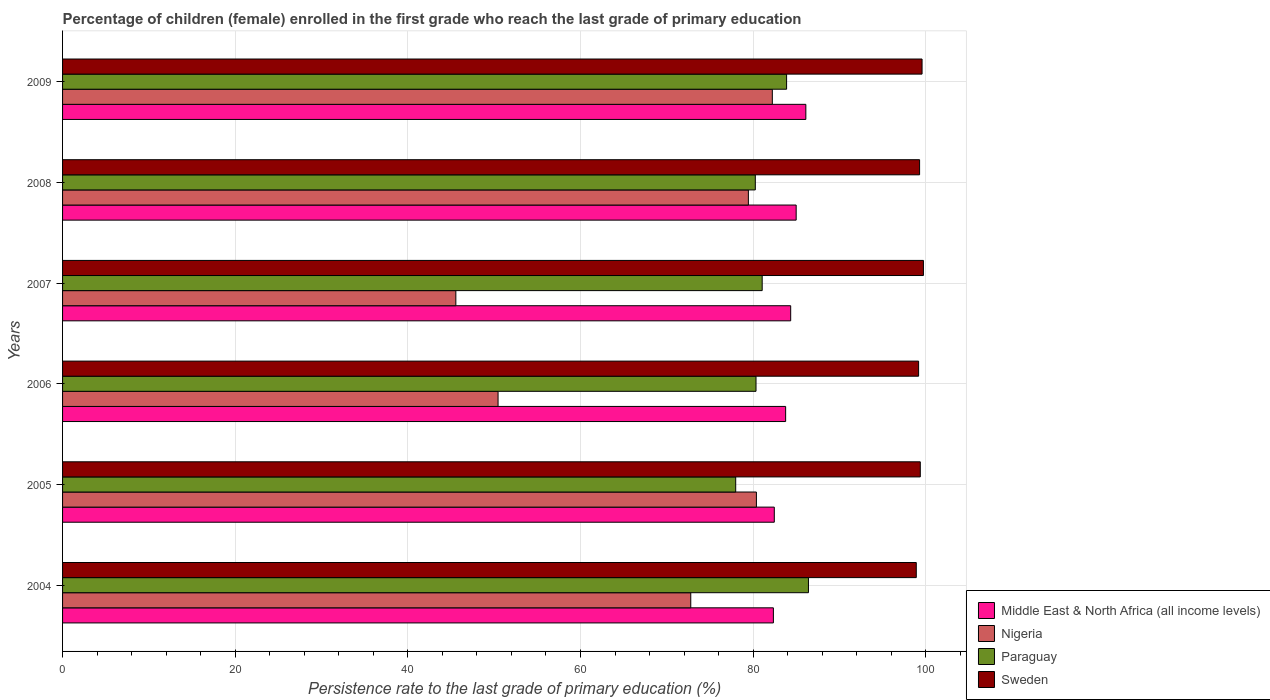How many different coloured bars are there?
Make the answer very short. 4. How many groups of bars are there?
Keep it short and to the point. 6. Are the number of bars per tick equal to the number of legend labels?
Give a very brief answer. Yes. How many bars are there on the 6th tick from the top?
Ensure brevity in your answer.  4. What is the label of the 2nd group of bars from the top?
Your answer should be compact. 2008. In how many cases, is the number of bars for a given year not equal to the number of legend labels?
Offer a terse response. 0. What is the persistence rate of children in Middle East & North Africa (all income levels) in 2004?
Keep it short and to the point. 82.34. Across all years, what is the maximum persistence rate of children in Nigeria?
Provide a short and direct response. 82.22. Across all years, what is the minimum persistence rate of children in Middle East & North Africa (all income levels)?
Keep it short and to the point. 82.34. In which year was the persistence rate of children in Paraguay maximum?
Make the answer very short. 2004. In which year was the persistence rate of children in Sweden minimum?
Offer a terse response. 2004. What is the total persistence rate of children in Nigeria in the graph?
Make the answer very short. 410.82. What is the difference between the persistence rate of children in Paraguay in 2005 and that in 2009?
Give a very brief answer. -5.9. What is the difference between the persistence rate of children in Sweden in 2004 and the persistence rate of children in Nigeria in 2005?
Offer a very short reply. 18.52. What is the average persistence rate of children in Nigeria per year?
Give a very brief answer. 68.47. In the year 2009, what is the difference between the persistence rate of children in Sweden and persistence rate of children in Middle East & North Africa (all income levels)?
Ensure brevity in your answer.  13.46. In how many years, is the persistence rate of children in Middle East & North Africa (all income levels) greater than 52 %?
Offer a very short reply. 6. What is the ratio of the persistence rate of children in Nigeria in 2007 to that in 2008?
Give a very brief answer. 0.57. Is the difference between the persistence rate of children in Sweden in 2005 and 2008 greater than the difference between the persistence rate of children in Middle East & North Africa (all income levels) in 2005 and 2008?
Keep it short and to the point. Yes. What is the difference between the highest and the second highest persistence rate of children in Nigeria?
Your answer should be compact. 1.84. What is the difference between the highest and the lowest persistence rate of children in Paraguay?
Keep it short and to the point. 8.43. Is the sum of the persistence rate of children in Nigeria in 2004 and 2005 greater than the maximum persistence rate of children in Paraguay across all years?
Offer a very short reply. Yes. Is it the case that in every year, the sum of the persistence rate of children in Sweden and persistence rate of children in Paraguay is greater than the sum of persistence rate of children in Middle East & North Africa (all income levels) and persistence rate of children in Nigeria?
Offer a terse response. Yes. What does the 1st bar from the top in 2008 represents?
Your answer should be very brief. Sweden. Is it the case that in every year, the sum of the persistence rate of children in Middle East & North Africa (all income levels) and persistence rate of children in Paraguay is greater than the persistence rate of children in Nigeria?
Provide a succinct answer. Yes. How many bars are there?
Provide a short and direct response. 24. Does the graph contain any zero values?
Your answer should be compact. No. Does the graph contain grids?
Offer a very short reply. Yes. How many legend labels are there?
Your answer should be compact. 4. What is the title of the graph?
Make the answer very short. Percentage of children (female) enrolled in the first grade who reach the last grade of primary education. What is the label or title of the X-axis?
Provide a succinct answer. Persistence rate to the last grade of primary education (%). What is the label or title of the Y-axis?
Offer a terse response. Years. What is the Persistence rate to the last grade of primary education (%) in Middle East & North Africa (all income levels) in 2004?
Give a very brief answer. 82.34. What is the Persistence rate to the last grade of primary education (%) in Nigeria in 2004?
Keep it short and to the point. 72.77. What is the Persistence rate to the last grade of primary education (%) in Paraguay in 2004?
Offer a very short reply. 86.41. What is the Persistence rate to the last grade of primary education (%) of Sweden in 2004?
Make the answer very short. 98.9. What is the Persistence rate to the last grade of primary education (%) of Middle East & North Africa (all income levels) in 2005?
Your response must be concise. 82.45. What is the Persistence rate to the last grade of primary education (%) of Nigeria in 2005?
Ensure brevity in your answer.  80.38. What is the Persistence rate to the last grade of primary education (%) of Paraguay in 2005?
Offer a very short reply. 77.98. What is the Persistence rate to the last grade of primary education (%) of Sweden in 2005?
Give a very brief answer. 99.36. What is the Persistence rate to the last grade of primary education (%) of Middle East & North Africa (all income levels) in 2006?
Make the answer very short. 83.76. What is the Persistence rate to the last grade of primary education (%) of Nigeria in 2006?
Offer a very short reply. 50.45. What is the Persistence rate to the last grade of primary education (%) of Paraguay in 2006?
Provide a short and direct response. 80.33. What is the Persistence rate to the last grade of primary education (%) of Sweden in 2006?
Give a very brief answer. 99.17. What is the Persistence rate to the last grade of primary education (%) in Middle East & North Africa (all income levels) in 2007?
Your answer should be compact. 84.35. What is the Persistence rate to the last grade of primary education (%) of Nigeria in 2007?
Give a very brief answer. 45.56. What is the Persistence rate to the last grade of primary education (%) of Paraguay in 2007?
Ensure brevity in your answer.  81.05. What is the Persistence rate to the last grade of primary education (%) of Sweden in 2007?
Provide a succinct answer. 99.72. What is the Persistence rate to the last grade of primary education (%) of Middle East & North Africa (all income levels) in 2008?
Offer a very short reply. 84.98. What is the Persistence rate to the last grade of primary education (%) in Nigeria in 2008?
Give a very brief answer. 79.44. What is the Persistence rate to the last grade of primary education (%) of Paraguay in 2008?
Keep it short and to the point. 80.25. What is the Persistence rate to the last grade of primary education (%) of Sweden in 2008?
Give a very brief answer. 99.28. What is the Persistence rate to the last grade of primary education (%) in Middle East & North Africa (all income levels) in 2009?
Give a very brief answer. 86.1. What is the Persistence rate to the last grade of primary education (%) of Nigeria in 2009?
Your response must be concise. 82.22. What is the Persistence rate to the last grade of primary education (%) of Paraguay in 2009?
Your answer should be compact. 83.87. What is the Persistence rate to the last grade of primary education (%) of Sweden in 2009?
Provide a short and direct response. 99.57. Across all years, what is the maximum Persistence rate to the last grade of primary education (%) in Middle East & North Africa (all income levels)?
Give a very brief answer. 86.1. Across all years, what is the maximum Persistence rate to the last grade of primary education (%) of Nigeria?
Provide a short and direct response. 82.22. Across all years, what is the maximum Persistence rate to the last grade of primary education (%) in Paraguay?
Provide a succinct answer. 86.41. Across all years, what is the maximum Persistence rate to the last grade of primary education (%) in Sweden?
Your response must be concise. 99.72. Across all years, what is the minimum Persistence rate to the last grade of primary education (%) of Middle East & North Africa (all income levels)?
Your answer should be very brief. 82.34. Across all years, what is the minimum Persistence rate to the last grade of primary education (%) of Nigeria?
Provide a succinct answer. 45.56. Across all years, what is the minimum Persistence rate to the last grade of primary education (%) in Paraguay?
Your response must be concise. 77.98. Across all years, what is the minimum Persistence rate to the last grade of primary education (%) in Sweden?
Give a very brief answer. 98.9. What is the total Persistence rate to the last grade of primary education (%) of Middle East & North Africa (all income levels) in the graph?
Give a very brief answer. 503.99. What is the total Persistence rate to the last grade of primary education (%) in Nigeria in the graph?
Keep it short and to the point. 410.82. What is the total Persistence rate to the last grade of primary education (%) of Paraguay in the graph?
Make the answer very short. 489.88. What is the total Persistence rate to the last grade of primary education (%) of Sweden in the graph?
Offer a terse response. 595.99. What is the difference between the Persistence rate to the last grade of primary education (%) of Middle East & North Africa (all income levels) in 2004 and that in 2005?
Provide a short and direct response. -0.1. What is the difference between the Persistence rate to the last grade of primary education (%) of Nigeria in 2004 and that in 2005?
Your answer should be very brief. -7.61. What is the difference between the Persistence rate to the last grade of primary education (%) in Paraguay in 2004 and that in 2005?
Offer a terse response. 8.43. What is the difference between the Persistence rate to the last grade of primary education (%) in Sweden in 2004 and that in 2005?
Provide a succinct answer. -0.46. What is the difference between the Persistence rate to the last grade of primary education (%) in Middle East & North Africa (all income levels) in 2004 and that in 2006?
Your answer should be compact. -1.42. What is the difference between the Persistence rate to the last grade of primary education (%) of Nigeria in 2004 and that in 2006?
Keep it short and to the point. 22.32. What is the difference between the Persistence rate to the last grade of primary education (%) in Paraguay in 2004 and that in 2006?
Ensure brevity in your answer.  6.07. What is the difference between the Persistence rate to the last grade of primary education (%) of Sweden in 2004 and that in 2006?
Your answer should be compact. -0.27. What is the difference between the Persistence rate to the last grade of primary education (%) of Middle East & North Africa (all income levels) in 2004 and that in 2007?
Offer a very short reply. -2. What is the difference between the Persistence rate to the last grade of primary education (%) of Nigeria in 2004 and that in 2007?
Offer a terse response. 27.21. What is the difference between the Persistence rate to the last grade of primary education (%) in Paraguay in 2004 and that in 2007?
Your answer should be compact. 5.36. What is the difference between the Persistence rate to the last grade of primary education (%) of Sweden in 2004 and that in 2007?
Offer a terse response. -0.83. What is the difference between the Persistence rate to the last grade of primary education (%) of Middle East & North Africa (all income levels) in 2004 and that in 2008?
Ensure brevity in your answer.  -2.64. What is the difference between the Persistence rate to the last grade of primary education (%) in Nigeria in 2004 and that in 2008?
Provide a short and direct response. -6.67. What is the difference between the Persistence rate to the last grade of primary education (%) in Paraguay in 2004 and that in 2008?
Provide a succinct answer. 6.15. What is the difference between the Persistence rate to the last grade of primary education (%) of Sweden in 2004 and that in 2008?
Your response must be concise. -0.38. What is the difference between the Persistence rate to the last grade of primary education (%) in Middle East & North Africa (all income levels) in 2004 and that in 2009?
Offer a terse response. -3.76. What is the difference between the Persistence rate to the last grade of primary education (%) of Nigeria in 2004 and that in 2009?
Provide a succinct answer. -9.45. What is the difference between the Persistence rate to the last grade of primary education (%) of Paraguay in 2004 and that in 2009?
Keep it short and to the point. 2.53. What is the difference between the Persistence rate to the last grade of primary education (%) of Sweden in 2004 and that in 2009?
Give a very brief answer. -0.67. What is the difference between the Persistence rate to the last grade of primary education (%) of Middle East & North Africa (all income levels) in 2005 and that in 2006?
Provide a succinct answer. -1.31. What is the difference between the Persistence rate to the last grade of primary education (%) of Nigeria in 2005 and that in 2006?
Ensure brevity in your answer.  29.93. What is the difference between the Persistence rate to the last grade of primary education (%) in Paraguay in 2005 and that in 2006?
Your answer should be very brief. -2.35. What is the difference between the Persistence rate to the last grade of primary education (%) in Sweden in 2005 and that in 2006?
Offer a terse response. 0.19. What is the difference between the Persistence rate to the last grade of primary education (%) of Middle East & North Africa (all income levels) in 2005 and that in 2007?
Provide a short and direct response. -1.9. What is the difference between the Persistence rate to the last grade of primary education (%) in Nigeria in 2005 and that in 2007?
Give a very brief answer. 34.82. What is the difference between the Persistence rate to the last grade of primary education (%) of Paraguay in 2005 and that in 2007?
Provide a succinct answer. -3.07. What is the difference between the Persistence rate to the last grade of primary education (%) in Sweden in 2005 and that in 2007?
Your answer should be very brief. -0.36. What is the difference between the Persistence rate to the last grade of primary education (%) in Middle East & North Africa (all income levels) in 2005 and that in 2008?
Make the answer very short. -2.53. What is the difference between the Persistence rate to the last grade of primary education (%) of Nigeria in 2005 and that in 2008?
Provide a short and direct response. 0.93. What is the difference between the Persistence rate to the last grade of primary education (%) of Paraguay in 2005 and that in 2008?
Offer a very short reply. -2.27. What is the difference between the Persistence rate to the last grade of primary education (%) of Sweden in 2005 and that in 2008?
Offer a terse response. 0.08. What is the difference between the Persistence rate to the last grade of primary education (%) of Middle East & North Africa (all income levels) in 2005 and that in 2009?
Keep it short and to the point. -3.66. What is the difference between the Persistence rate to the last grade of primary education (%) of Nigeria in 2005 and that in 2009?
Ensure brevity in your answer.  -1.84. What is the difference between the Persistence rate to the last grade of primary education (%) of Paraguay in 2005 and that in 2009?
Provide a short and direct response. -5.9. What is the difference between the Persistence rate to the last grade of primary education (%) of Sweden in 2005 and that in 2009?
Make the answer very short. -0.2. What is the difference between the Persistence rate to the last grade of primary education (%) of Middle East & North Africa (all income levels) in 2006 and that in 2007?
Your answer should be very brief. -0.58. What is the difference between the Persistence rate to the last grade of primary education (%) of Nigeria in 2006 and that in 2007?
Your answer should be very brief. 4.89. What is the difference between the Persistence rate to the last grade of primary education (%) of Paraguay in 2006 and that in 2007?
Provide a succinct answer. -0.72. What is the difference between the Persistence rate to the last grade of primary education (%) in Sweden in 2006 and that in 2007?
Provide a succinct answer. -0.56. What is the difference between the Persistence rate to the last grade of primary education (%) of Middle East & North Africa (all income levels) in 2006 and that in 2008?
Offer a terse response. -1.22. What is the difference between the Persistence rate to the last grade of primary education (%) in Nigeria in 2006 and that in 2008?
Make the answer very short. -29. What is the difference between the Persistence rate to the last grade of primary education (%) in Paraguay in 2006 and that in 2008?
Provide a short and direct response. 0.08. What is the difference between the Persistence rate to the last grade of primary education (%) in Sweden in 2006 and that in 2008?
Keep it short and to the point. -0.11. What is the difference between the Persistence rate to the last grade of primary education (%) of Middle East & North Africa (all income levels) in 2006 and that in 2009?
Your answer should be compact. -2.34. What is the difference between the Persistence rate to the last grade of primary education (%) in Nigeria in 2006 and that in 2009?
Provide a short and direct response. -31.77. What is the difference between the Persistence rate to the last grade of primary education (%) of Paraguay in 2006 and that in 2009?
Provide a succinct answer. -3.54. What is the difference between the Persistence rate to the last grade of primary education (%) in Sweden in 2006 and that in 2009?
Offer a terse response. -0.4. What is the difference between the Persistence rate to the last grade of primary education (%) in Middle East & North Africa (all income levels) in 2007 and that in 2008?
Your response must be concise. -0.64. What is the difference between the Persistence rate to the last grade of primary education (%) of Nigeria in 2007 and that in 2008?
Provide a short and direct response. -33.89. What is the difference between the Persistence rate to the last grade of primary education (%) of Paraguay in 2007 and that in 2008?
Make the answer very short. 0.8. What is the difference between the Persistence rate to the last grade of primary education (%) of Sweden in 2007 and that in 2008?
Offer a terse response. 0.44. What is the difference between the Persistence rate to the last grade of primary education (%) of Middle East & North Africa (all income levels) in 2007 and that in 2009?
Your answer should be compact. -1.76. What is the difference between the Persistence rate to the last grade of primary education (%) in Nigeria in 2007 and that in 2009?
Your answer should be very brief. -36.66. What is the difference between the Persistence rate to the last grade of primary education (%) of Paraguay in 2007 and that in 2009?
Provide a short and direct response. -2.83. What is the difference between the Persistence rate to the last grade of primary education (%) of Sweden in 2007 and that in 2009?
Keep it short and to the point. 0.16. What is the difference between the Persistence rate to the last grade of primary education (%) in Middle East & North Africa (all income levels) in 2008 and that in 2009?
Your answer should be very brief. -1.12. What is the difference between the Persistence rate to the last grade of primary education (%) in Nigeria in 2008 and that in 2009?
Your answer should be compact. -2.77. What is the difference between the Persistence rate to the last grade of primary education (%) in Paraguay in 2008 and that in 2009?
Offer a very short reply. -3.62. What is the difference between the Persistence rate to the last grade of primary education (%) of Sweden in 2008 and that in 2009?
Offer a very short reply. -0.28. What is the difference between the Persistence rate to the last grade of primary education (%) in Middle East & North Africa (all income levels) in 2004 and the Persistence rate to the last grade of primary education (%) in Nigeria in 2005?
Your response must be concise. 1.97. What is the difference between the Persistence rate to the last grade of primary education (%) in Middle East & North Africa (all income levels) in 2004 and the Persistence rate to the last grade of primary education (%) in Paraguay in 2005?
Your answer should be compact. 4.37. What is the difference between the Persistence rate to the last grade of primary education (%) of Middle East & North Africa (all income levels) in 2004 and the Persistence rate to the last grade of primary education (%) of Sweden in 2005?
Your answer should be very brief. -17.02. What is the difference between the Persistence rate to the last grade of primary education (%) of Nigeria in 2004 and the Persistence rate to the last grade of primary education (%) of Paraguay in 2005?
Offer a very short reply. -5.21. What is the difference between the Persistence rate to the last grade of primary education (%) of Nigeria in 2004 and the Persistence rate to the last grade of primary education (%) of Sweden in 2005?
Make the answer very short. -26.59. What is the difference between the Persistence rate to the last grade of primary education (%) in Paraguay in 2004 and the Persistence rate to the last grade of primary education (%) in Sweden in 2005?
Keep it short and to the point. -12.96. What is the difference between the Persistence rate to the last grade of primary education (%) of Middle East & North Africa (all income levels) in 2004 and the Persistence rate to the last grade of primary education (%) of Nigeria in 2006?
Your answer should be very brief. 31.9. What is the difference between the Persistence rate to the last grade of primary education (%) in Middle East & North Africa (all income levels) in 2004 and the Persistence rate to the last grade of primary education (%) in Paraguay in 2006?
Your answer should be very brief. 2.01. What is the difference between the Persistence rate to the last grade of primary education (%) in Middle East & North Africa (all income levels) in 2004 and the Persistence rate to the last grade of primary education (%) in Sweden in 2006?
Keep it short and to the point. -16.82. What is the difference between the Persistence rate to the last grade of primary education (%) of Nigeria in 2004 and the Persistence rate to the last grade of primary education (%) of Paraguay in 2006?
Give a very brief answer. -7.56. What is the difference between the Persistence rate to the last grade of primary education (%) of Nigeria in 2004 and the Persistence rate to the last grade of primary education (%) of Sweden in 2006?
Keep it short and to the point. -26.4. What is the difference between the Persistence rate to the last grade of primary education (%) of Paraguay in 2004 and the Persistence rate to the last grade of primary education (%) of Sweden in 2006?
Give a very brief answer. -12.76. What is the difference between the Persistence rate to the last grade of primary education (%) in Middle East & North Africa (all income levels) in 2004 and the Persistence rate to the last grade of primary education (%) in Nigeria in 2007?
Provide a succinct answer. 36.79. What is the difference between the Persistence rate to the last grade of primary education (%) of Middle East & North Africa (all income levels) in 2004 and the Persistence rate to the last grade of primary education (%) of Paraguay in 2007?
Give a very brief answer. 1.3. What is the difference between the Persistence rate to the last grade of primary education (%) of Middle East & North Africa (all income levels) in 2004 and the Persistence rate to the last grade of primary education (%) of Sweden in 2007?
Provide a succinct answer. -17.38. What is the difference between the Persistence rate to the last grade of primary education (%) of Nigeria in 2004 and the Persistence rate to the last grade of primary education (%) of Paraguay in 2007?
Your answer should be very brief. -8.27. What is the difference between the Persistence rate to the last grade of primary education (%) of Nigeria in 2004 and the Persistence rate to the last grade of primary education (%) of Sweden in 2007?
Give a very brief answer. -26.95. What is the difference between the Persistence rate to the last grade of primary education (%) in Paraguay in 2004 and the Persistence rate to the last grade of primary education (%) in Sweden in 2007?
Give a very brief answer. -13.32. What is the difference between the Persistence rate to the last grade of primary education (%) of Middle East & North Africa (all income levels) in 2004 and the Persistence rate to the last grade of primary education (%) of Nigeria in 2008?
Your answer should be compact. 2.9. What is the difference between the Persistence rate to the last grade of primary education (%) in Middle East & North Africa (all income levels) in 2004 and the Persistence rate to the last grade of primary education (%) in Paraguay in 2008?
Ensure brevity in your answer.  2.09. What is the difference between the Persistence rate to the last grade of primary education (%) of Middle East & North Africa (all income levels) in 2004 and the Persistence rate to the last grade of primary education (%) of Sweden in 2008?
Give a very brief answer. -16.94. What is the difference between the Persistence rate to the last grade of primary education (%) of Nigeria in 2004 and the Persistence rate to the last grade of primary education (%) of Paraguay in 2008?
Give a very brief answer. -7.48. What is the difference between the Persistence rate to the last grade of primary education (%) in Nigeria in 2004 and the Persistence rate to the last grade of primary education (%) in Sweden in 2008?
Ensure brevity in your answer.  -26.51. What is the difference between the Persistence rate to the last grade of primary education (%) of Paraguay in 2004 and the Persistence rate to the last grade of primary education (%) of Sweden in 2008?
Keep it short and to the point. -12.88. What is the difference between the Persistence rate to the last grade of primary education (%) in Middle East & North Africa (all income levels) in 2004 and the Persistence rate to the last grade of primary education (%) in Nigeria in 2009?
Ensure brevity in your answer.  0.12. What is the difference between the Persistence rate to the last grade of primary education (%) of Middle East & North Africa (all income levels) in 2004 and the Persistence rate to the last grade of primary education (%) of Paraguay in 2009?
Give a very brief answer. -1.53. What is the difference between the Persistence rate to the last grade of primary education (%) in Middle East & North Africa (all income levels) in 2004 and the Persistence rate to the last grade of primary education (%) in Sweden in 2009?
Provide a short and direct response. -17.22. What is the difference between the Persistence rate to the last grade of primary education (%) in Nigeria in 2004 and the Persistence rate to the last grade of primary education (%) in Paraguay in 2009?
Keep it short and to the point. -11.1. What is the difference between the Persistence rate to the last grade of primary education (%) in Nigeria in 2004 and the Persistence rate to the last grade of primary education (%) in Sweden in 2009?
Provide a succinct answer. -26.79. What is the difference between the Persistence rate to the last grade of primary education (%) of Paraguay in 2004 and the Persistence rate to the last grade of primary education (%) of Sweden in 2009?
Your answer should be compact. -13.16. What is the difference between the Persistence rate to the last grade of primary education (%) of Middle East & North Africa (all income levels) in 2005 and the Persistence rate to the last grade of primary education (%) of Nigeria in 2006?
Your answer should be very brief. 32. What is the difference between the Persistence rate to the last grade of primary education (%) of Middle East & North Africa (all income levels) in 2005 and the Persistence rate to the last grade of primary education (%) of Paraguay in 2006?
Make the answer very short. 2.12. What is the difference between the Persistence rate to the last grade of primary education (%) in Middle East & North Africa (all income levels) in 2005 and the Persistence rate to the last grade of primary education (%) in Sweden in 2006?
Ensure brevity in your answer.  -16.72. What is the difference between the Persistence rate to the last grade of primary education (%) of Nigeria in 2005 and the Persistence rate to the last grade of primary education (%) of Paraguay in 2006?
Provide a succinct answer. 0.05. What is the difference between the Persistence rate to the last grade of primary education (%) in Nigeria in 2005 and the Persistence rate to the last grade of primary education (%) in Sweden in 2006?
Provide a short and direct response. -18.79. What is the difference between the Persistence rate to the last grade of primary education (%) of Paraguay in 2005 and the Persistence rate to the last grade of primary education (%) of Sweden in 2006?
Offer a terse response. -21.19. What is the difference between the Persistence rate to the last grade of primary education (%) of Middle East & North Africa (all income levels) in 2005 and the Persistence rate to the last grade of primary education (%) of Nigeria in 2007?
Give a very brief answer. 36.89. What is the difference between the Persistence rate to the last grade of primary education (%) of Middle East & North Africa (all income levels) in 2005 and the Persistence rate to the last grade of primary education (%) of Paraguay in 2007?
Make the answer very short. 1.4. What is the difference between the Persistence rate to the last grade of primary education (%) in Middle East & North Africa (all income levels) in 2005 and the Persistence rate to the last grade of primary education (%) in Sweden in 2007?
Ensure brevity in your answer.  -17.28. What is the difference between the Persistence rate to the last grade of primary education (%) of Nigeria in 2005 and the Persistence rate to the last grade of primary education (%) of Paraguay in 2007?
Make the answer very short. -0.67. What is the difference between the Persistence rate to the last grade of primary education (%) of Nigeria in 2005 and the Persistence rate to the last grade of primary education (%) of Sweden in 2007?
Your answer should be compact. -19.35. What is the difference between the Persistence rate to the last grade of primary education (%) of Paraguay in 2005 and the Persistence rate to the last grade of primary education (%) of Sweden in 2007?
Offer a very short reply. -21.75. What is the difference between the Persistence rate to the last grade of primary education (%) in Middle East & North Africa (all income levels) in 2005 and the Persistence rate to the last grade of primary education (%) in Nigeria in 2008?
Provide a succinct answer. 3. What is the difference between the Persistence rate to the last grade of primary education (%) in Middle East & North Africa (all income levels) in 2005 and the Persistence rate to the last grade of primary education (%) in Paraguay in 2008?
Keep it short and to the point. 2.2. What is the difference between the Persistence rate to the last grade of primary education (%) in Middle East & North Africa (all income levels) in 2005 and the Persistence rate to the last grade of primary education (%) in Sweden in 2008?
Ensure brevity in your answer.  -16.83. What is the difference between the Persistence rate to the last grade of primary education (%) in Nigeria in 2005 and the Persistence rate to the last grade of primary education (%) in Paraguay in 2008?
Keep it short and to the point. 0.13. What is the difference between the Persistence rate to the last grade of primary education (%) in Nigeria in 2005 and the Persistence rate to the last grade of primary education (%) in Sweden in 2008?
Provide a short and direct response. -18.9. What is the difference between the Persistence rate to the last grade of primary education (%) of Paraguay in 2005 and the Persistence rate to the last grade of primary education (%) of Sweden in 2008?
Your response must be concise. -21.3. What is the difference between the Persistence rate to the last grade of primary education (%) of Middle East & North Africa (all income levels) in 2005 and the Persistence rate to the last grade of primary education (%) of Nigeria in 2009?
Provide a short and direct response. 0.23. What is the difference between the Persistence rate to the last grade of primary education (%) of Middle East & North Africa (all income levels) in 2005 and the Persistence rate to the last grade of primary education (%) of Paraguay in 2009?
Your response must be concise. -1.43. What is the difference between the Persistence rate to the last grade of primary education (%) of Middle East & North Africa (all income levels) in 2005 and the Persistence rate to the last grade of primary education (%) of Sweden in 2009?
Your response must be concise. -17.12. What is the difference between the Persistence rate to the last grade of primary education (%) in Nigeria in 2005 and the Persistence rate to the last grade of primary education (%) in Paraguay in 2009?
Ensure brevity in your answer.  -3.5. What is the difference between the Persistence rate to the last grade of primary education (%) of Nigeria in 2005 and the Persistence rate to the last grade of primary education (%) of Sweden in 2009?
Your answer should be very brief. -19.19. What is the difference between the Persistence rate to the last grade of primary education (%) of Paraguay in 2005 and the Persistence rate to the last grade of primary education (%) of Sweden in 2009?
Your response must be concise. -21.59. What is the difference between the Persistence rate to the last grade of primary education (%) of Middle East & North Africa (all income levels) in 2006 and the Persistence rate to the last grade of primary education (%) of Nigeria in 2007?
Make the answer very short. 38.21. What is the difference between the Persistence rate to the last grade of primary education (%) in Middle East & North Africa (all income levels) in 2006 and the Persistence rate to the last grade of primary education (%) in Paraguay in 2007?
Provide a succinct answer. 2.72. What is the difference between the Persistence rate to the last grade of primary education (%) in Middle East & North Africa (all income levels) in 2006 and the Persistence rate to the last grade of primary education (%) in Sweden in 2007?
Your answer should be compact. -15.96. What is the difference between the Persistence rate to the last grade of primary education (%) of Nigeria in 2006 and the Persistence rate to the last grade of primary education (%) of Paraguay in 2007?
Keep it short and to the point. -30.6. What is the difference between the Persistence rate to the last grade of primary education (%) of Nigeria in 2006 and the Persistence rate to the last grade of primary education (%) of Sweden in 2007?
Keep it short and to the point. -49.27. What is the difference between the Persistence rate to the last grade of primary education (%) in Paraguay in 2006 and the Persistence rate to the last grade of primary education (%) in Sweden in 2007?
Your answer should be very brief. -19.39. What is the difference between the Persistence rate to the last grade of primary education (%) of Middle East & North Africa (all income levels) in 2006 and the Persistence rate to the last grade of primary education (%) of Nigeria in 2008?
Keep it short and to the point. 4.32. What is the difference between the Persistence rate to the last grade of primary education (%) in Middle East & North Africa (all income levels) in 2006 and the Persistence rate to the last grade of primary education (%) in Paraguay in 2008?
Offer a very short reply. 3.51. What is the difference between the Persistence rate to the last grade of primary education (%) of Middle East & North Africa (all income levels) in 2006 and the Persistence rate to the last grade of primary education (%) of Sweden in 2008?
Keep it short and to the point. -15.52. What is the difference between the Persistence rate to the last grade of primary education (%) of Nigeria in 2006 and the Persistence rate to the last grade of primary education (%) of Paraguay in 2008?
Provide a short and direct response. -29.8. What is the difference between the Persistence rate to the last grade of primary education (%) of Nigeria in 2006 and the Persistence rate to the last grade of primary education (%) of Sweden in 2008?
Provide a short and direct response. -48.83. What is the difference between the Persistence rate to the last grade of primary education (%) of Paraguay in 2006 and the Persistence rate to the last grade of primary education (%) of Sweden in 2008?
Provide a succinct answer. -18.95. What is the difference between the Persistence rate to the last grade of primary education (%) of Middle East & North Africa (all income levels) in 2006 and the Persistence rate to the last grade of primary education (%) of Nigeria in 2009?
Offer a terse response. 1.54. What is the difference between the Persistence rate to the last grade of primary education (%) of Middle East & North Africa (all income levels) in 2006 and the Persistence rate to the last grade of primary education (%) of Paraguay in 2009?
Your answer should be very brief. -0.11. What is the difference between the Persistence rate to the last grade of primary education (%) of Middle East & North Africa (all income levels) in 2006 and the Persistence rate to the last grade of primary education (%) of Sweden in 2009?
Your answer should be compact. -15.8. What is the difference between the Persistence rate to the last grade of primary education (%) in Nigeria in 2006 and the Persistence rate to the last grade of primary education (%) in Paraguay in 2009?
Make the answer very short. -33.43. What is the difference between the Persistence rate to the last grade of primary education (%) of Nigeria in 2006 and the Persistence rate to the last grade of primary education (%) of Sweden in 2009?
Your answer should be very brief. -49.12. What is the difference between the Persistence rate to the last grade of primary education (%) in Paraguay in 2006 and the Persistence rate to the last grade of primary education (%) in Sweden in 2009?
Give a very brief answer. -19.23. What is the difference between the Persistence rate to the last grade of primary education (%) in Middle East & North Africa (all income levels) in 2007 and the Persistence rate to the last grade of primary education (%) in Nigeria in 2008?
Offer a very short reply. 4.9. What is the difference between the Persistence rate to the last grade of primary education (%) of Middle East & North Africa (all income levels) in 2007 and the Persistence rate to the last grade of primary education (%) of Paraguay in 2008?
Make the answer very short. 4.1. What is the difference between the Persistence rate to the last grade of primary education (%) in Middle East & North Africa (all income levels) in 2007 and the Persistence rate to the last grade of primary education (%) in Sweden in 2008?
Keep it short and to the point. -14.93. What is the difference between the Persistence rate to the last grade of primary education (%) in Nigeria in 2007 and the Persistence rate to the last grade of primary education (%) in Paraguay in 2008?
Ensure brevity in your answer.  -34.69. What is the difference between the Persistence rate to the last grade of primary education (%) of Nigeria in 2007 and the Persistence rate to the last grade of primary education (%) of Sweden in 2008?
Ensure brevity in your answer.  -53.72. What is the difference between the Persistence rate to the last grade of primary education (%) in Paraguay in 2007 and the Persistence rate to the last grade of primary education (%) in Sweden in 2008?
Ensure brevity in your answer.  -18.23. What is the difference between the Persistence rate to the last grade of primary education (%) in Middle East & North Africa (all income levels) in 2007 and the Persistence rate to the last grade of primary education (%) in Nigeria in 2009?
Provide a short and direct response. 2.13. What is the difference between the Persistence rate to the last grade of primary education (%) in Middle East & North Africa (all income levels) in 2007 and the Persistence rate to the last grade of primary education (%) in Paraguay in 2009?
Provide a succinct answer. 0.47. What is the difference between the Persistence rate to the last grade of primary education (%) of Middle East & North Africa (all income levels) in 2007 and the Persistence rate to the last grade of primary education (%) of Sweden in 2009?
Give a very brief answer. -15.22. What is the difference between the Persistence rate to the last grade of primary education (%) in Nigeria in 2007 and the Persistence rate to the last grade of primary education (%) in Paraguay in 2009?
Make the answer very short. -38.32. What is the difference between the Persistence rate to the last grade of primary education (%) of Nigeria in 2007 and the Persistence rate to the last grade of primary education (%) of Sweden in 2009?
Offer a terse response. -54.01. What is the difference between the Persistence rate to the last grade of primary education (%) in Paraguay in 2007 and the Persistence rate to the last grade of primary education (%) in Sweden in 2009?
Give a very brief answer. -18.52. What is the difference between the Persistence rate to the last grade of primary education (%) of Middle East & North Africa (all income levels) in 2008 and the Persistence rate to the last grade of primary education (%) of Nigeria in 2009?
Provide a short and direct response. 2.76. What is the difference between the Persistence rate to the last grade of primary education (%) of Middle East & North Africa (all income levels) in 2008 and the Persistence rate to the last grade of primary education (%) of Paraguay in 2009?
Provide a succinct answer. 1.11. What is the difference between the Persistence rate to the last grade of primary education (%) in Middle East & North Africa (all income levels) in 2008 and the Persistence rate to the last grade of primary education (%) in Sweden in 2009?
Make the answer very short. -14.58. What is the difference between the Persistence rate to the last grade of primary education (%) of Nigeria in 2008 and the Persistence rate to the last grade of primary education (%) of Paraguay in 2009?
Your answer should be compact. -4.43. What is the difference between the Persistence rate to the last grade of primary education (%) of Nigeria in 2008 and the Persistence rate to the last grade of primary education (%) of Sweden in 2009?
Your response must be concise. -20.12. What is the difference between the Persistence rate to the last grade of primary education (%) in Paraguay in 2008 and the Persistence rate to the last grade of primary education (%) in Sweden in 2009?
Ensure brevity in your answer.  -19.32. What is the average Persistence rate to the last grade of primary education (%) in Middle East & North Africa (all income levels) per year?
Keep it short and to the point. 84. What is the average Persistence rate to the last grade of primary education (%) of Nigeria per year?
Keep it short and to the point. 68.47. What is the average Persistence rate to the last grade of primary education (%) of Paraguay per year?
Keep it short and to the point. 81.65. What is the average Persistence rate to the last grade of primary education (%) of Sweden per year?
Your answer should be compact. 99.33. In the year 2004, what is the difference between the Persistence rate to the last grade of primary education (%) in Middle East & North Africa (all income levels) and Persistence rate to the last grade of primary education (%) in Nigeria?
Provide a succinct answer. 9.57. In the year 2004, what is the difference between the Persistence rate to the last grade of primary education (%) in Middle East & North Africa (all income levels) and Persistence rate to the last grade of primary education (%) in Paraguay?
Offer a very short reply. -4.06. In the year 2004, what is the difference between the Persistence rate to the last grade of primary education (%) in Middle East & North Africa (all income levels) and Persistence rate to the last grade of primary education (%) in Sweden?
Your answer should be very brief. -16.55. In the year 2004, what is the difference between the Persistence rate to the last grade of primary education (%) in Nigeria and Persistence rate to the last grade of primary education (%) in Paraguay?
Offer a terse response. -13.63. In the year 2004, what is the difference between the Persistence rate to the last grade of primary education (%) of Nigeria and Persistence rate to the last grade of primary education (%) of Sweden?
Your answer should be very brief. -26.13. In the year 2004, what is the difference between the Persistence rate to the last grade of primary education (%) of Paraguay and Persistence rate to the last grade of primary education (%) of Sweden?
Keep it short and to the point. -12.49. In the year 2005, what is the difference between the Persistence rate to the last grade of primary education (%) in Middle East & North Africa (all income levels) and Persistence rate to the last grade of primary education (%) in Nigeria?
Your answer should be very brief. 2.07. In the year 2005, what is the difference between the Persistence rate to the last grade of primary education (%) in Middle East & North Africa (all income levels) and Persistence rate to the last grade of primary education (%) in Paraguay?
Make the answer very short. 4.47. In the year 2005, what is the difference between the Persistence rate to the last grade of primary education (%) of Middle East & North Africa (all income levels) and Persistence rate to the last grade of primary education (%) of Sweden?
Your response must be concise. -16.91. In the year 2005, what is the difference between the Persistence rate to the last grade of primary education (%) of Nigeria and Persistence rate to the last grade of primary education (%) of Paraguay?
Provide a succinct answer. 2.4. In the year 2005, what is the difference between the Persistence rate to the last grade of primary education (%) in Nigeria and Persistence rate to the last grade of primary education (%) in Sweden?
Make the answer very short. -18.98. In the year 2005, what is the difference between the Persistence rate to the last grade of primary education (%) of Paraguay and Persistence rate to the last grade of primary education (%) of Sweden?
Provide a short and direct response. -21.38. In the year 2006, what is the difference between the Persistence rate to the last grade of primary education (%) of Middle East & North Africa (all income levels) and Persistence rate to the last grade of primary education (%) of Nigeria?
Your answer should be very brief. 33.31. In the year 2006, what is the difference between the Persistence rate to the last grade of primary education (%) in Middle East & North Africa (all income levels) and Persistence rate to the last grade of primary education (%) in Paraguay?
Provide a succinct answer. 3.43. In the year 2006, what is the difference between the Persistence rate to the last grade of primary education (%) of Middle East & North Africa (all income levels) and Persistence rate to the last grade of primary education (%) of Sweden?
Keep it short and to the point. -15.4. In the year 2006, what is the difference between the Persistence rate to the last grade of primary education (%) in Nigeria and Persistence rate to the last grade of primary education (%) in Paraguay?
Make the answer very short. -29.88. In the year 2006, what is the difference between the Persistence rate to the last grade of primary education (%) of Nigeria and Persistence rate to the last grade of primary education (%) of Sweden?
Make the answer very short. -48.72. In the year 2006, what is the difference between the Persistence rate to the last grade of primary education (%) of Paraguay and Persistence rate to the last grade of primary education (%) of Sweden?
Offer a terse response. -18.84. In the year 2007, what is the difference between the Persistence rate to the last grade of primary education (%) of Middle East & North Africa (all income levels) and Persistence rate to the last grade of primary education (%) of Nigeria?
Ensure brevity in your answer.  38.79. In the year 2007, what is the difference between the Persistence rate to the last grade of primary education (%) of Middle East & North Africa (all income levels) and Persistence rate to the last grade of primary education (%) of Paraguay?
Offer a terse response. 3.3. In the year 2007, what is the difference between the Persistence rate to the last grade of primary education (%) of Middle East & North Africa (all income levels) and Persistence rate to the last grade of primary education (%) of Sweden?
Keep it short and to the point. -15.38. In the year 2007, what is the difference between the Persistence rate to the last grade of primary education (%) of Nigeria and Persistence rate to the last grade of primary education (%) of Paraguay?
Keep it short and to the point. -35.49. In the year 2007, what is the difference between the Persistence rate to the last grade of primary education (%) of Nigeria and Persistence rate to the last grade of primary education (%) of Sweden?
Offer a very short reply. -54.17. In the year 2007, what is the difference between the Persistence rate to the last grade of primary education (%) of Paraguay and Persistence rate to the last grade of primary education (%) of Sweden?
Make the answer very short. -18.68. In the year 2008, what is the difference between the Persistence rate to the last grade of primary education (%) in Middle East & North Africa (all income levels) and Persistence rate to the last grade of primary education (%) in Nigeria?
Provide a succinct answer. 5.54. In the year 2008, what is the difference between the Persistence rate to the last grade of primary education (%) in Middle East & North Africa (all income levels) and Persistence rate to the last grade of primary education (%) in Paraguay?
Ensure brevity in your answer.  4.73. In the year 2008, what is the difference between the Persistence rate to the last grade of primary education (%) of Middle East & North Africa (all income levels) and Persistence rate to the last grade of primary education (%) of Sweden?
Your answer should be compact. -14.3. In the year 2008, what is the difference between the Persistence rate to the last grade of primary education (%) of Nigeria and Persistence rate to the last grade of primary education (%) of Paraguay?
Your answer should be compact. -0.81. In the year 2008, what is the difference between the Persistence rate to the last grade of primary education (%) of Nigeria and Persistence rate to the last grade of primary education (%) of Sweden?
Provide a short and direct response. -19.84. In the year 2008, what is the difference between the Persistence rate to the last grade of primary education (%) in Paraguay and Persistence rate to the last grade of primary education (%) in Sweden?
Ensure brevity in your answer.  -19.03. In the year 2009, what is the difference between the Persistence rate to the last grade of primary education (%) of Middle East & North Africa (all income levels) and Persistence rate to the last grade of primary education (%) of Nigeria?
Make the answer very short. 3.88. In the year 2009, what is the difference between the Persistence rate to the last grade of primary education (%) in Middle East & North Africa (all income levels) and Persistence rate to the last grade of primary education (%) in Paraguay?
Ensure brevity in your answer.  2.23. In the year 2009, what is the difference between the Persistence rate to the last grade of primary education (%) in Middle East & North Africa (all income levels) and Persistence rate to the last grade of primary education (%) in Sweden?
Give a very brief answer. -13.46. In the year 2009, what is the difference between the Persistence rate to the last grade of primary education (%) in Nigeria and Persistence rate to the last grade of primary education (%) in Paraguay?
Ensure brevity in your answer.  -1.65. In the year 2009, what is the difference between the Persistence rate to the last grade of primary education (%) of Nigeria and Persistence rate to the last grade of primary education (%) of Sweden?
Offer a very short reply. -17.35. In the year 2009, what is the difference between the Persistence rate to the last grade of primary education (%) in Paraguay and Persistence rate to the last grade of primary education (%) in Sweden?
Give a very brief answer. -15.69. What is the ratio of the Persistence rate to the last grade of primary education (%) in Nigeria in 2004 to that in 2005?
Provide a succinct answer. 0.91. What is the ratio of the Persistence rate to the last grade of primary education (%) of Paraguay in 2004 to that in 2005?
Give a very brief answer. 1.11. What is the ratio of the Persistence rate to the last grade of primary education (%) in Middle East & North Africa (all income levels) in 2004 to that in 2006?
Keep it short and to the point. 0.98. What is the ratio of the Persistence rate to the last grade of primary education (%) in Nigeria in 2004 to that in 2006?
Your answer should be compact. 1.44. What is the ratio of the Persistence rate to the last grade of primary education (%) in Paraguay in 2004 to that in 2006?
Give a very brief answer. 1.08. What is the ratio of the Persistence rate to the last grade of primary education (%) in Sweden in 2004 to that in 2006?
Your answer should be compact. 1. What is the ratio of the Persistence rate to the last grade of primary education (%) of Middle East & North Africa (all income levels) in 2004 to that in 2007?
Give a very brief answer. 0.98. What is the ratio of the Persistence rate to the last grade of primary education (%) in Nigeria in 2004 to that in 2007?
Offer a very short reply. 1.6. What is the ratio of the Persistence rate to the last grade of primary education (%) of Paraguay in 2004 to that in 2007?
Offer a terse response. 1.07. What is the ratio of the Persistence rate to the last grade of primary education (%) of Sweden in 2004 to that in 2007?
Provide a short and direct response. 0.99. What is the ratio of the Persistence rate to the last grade of primary education (%) in Middle East & North Africa (all income levels) in 2004 to that in 2008?
Provide a short and direct response. 0.97. What is the ratio of the Persistence rate to the last grade of primary education (%) of Nigeria in 2004 to that in 2008?
Make the answer very short. 0.92. What is the ratio of the Persistence rate to the last grade of primary education (%) in Paraguay in 2004 to that in 2008?
Give a very brief answer. 1.08. What is the ratio of the Persistence rate to the last grade of primary education (%) of Sweden in 2004 to that in 2008?
Provide a short and direct response. 1. What is the ratio of the Persistence rate to the last grade of primary education (%) of Middle East & North Africa (all income levels) in 2004 to that in 2009?
Your answer should be compact. 0.96. What is the ratio of the Persistence rate to the last grade of primary education (%) of Nigeria in 2004 to that in 2009?
Provide a succinct answer. 0.89. What is the ratio of the Persistence rate to the last grade of primary education (%) of Paraguay in 2004 to that in 2009?
Offer a very short reply. 1.03. What is the ratio of the Persistence rate to the last grade of primary education (%) in Sweden in 2004 to that in 2009?
Make the answer very short. 0.99. What is the ratio of the Persistence rate to the last grade of primary education (%) of Middle East & North Africa (all income levels) in 2005 to that in 2006?
Keep it short and to the point. 0.98. What is the ratio of the Persistence rate to the last grade of primary education (%) of Nigeria in 2005 to that in 2006?
Give a very brief answer. 1.59. What is the ratio of the Persistence rate to the last grade of primary education (%) in Paraguay in 2005 to that in 2006?
Your response must be concise. 0.97. What is the ratio of the Persistence rate to the last grade of primary education (%) in Sweden in 2005 to that in 2006?
Your answer should be very brief. 1. What is the ratio of the Persistence rate to the last grade of primary education (%) of Middle East & North Africa (all income levels) in 2005 to that in 2007?
Ensure brevity in your answer.  0.98. What is the ratio of the Persistence rate to the last grade of primary education (%) of Nigeria in 2005 to that in 2007?
Your answer should be compact. 1.76. What is the ratio of the Persistence rate to the last grade of primary education (%) in Paraguay in 2005 to that in 2007?
Your answer should be compact. 0.96. What is the ratio of the Persistence rate to the last grade of primary education (%) in Sweden in 2005 to that in 2007?
Keep it short and to the point. 1. What is the ratio of the Persistence rate to the last grade of primary education (%) in Middle East & North Africa (all income levels) in 2005 to that in 2008?
Provide a succinct answer. 0.97. What is the ratio of the Persistence rate to the last grade of primary education (%) in Nigeria in 2005 to that in 2008?
Offer a terse response. 1.01. What is the ratio of the Persistence rate to the last grade of primary education (%) in Paraguay in 2005 to that in 2008?
Provide a short and direct response. 0.97. What is the ratio of the Persistence rate to the last grade of primary education (%) of Middle East & North Africa (all income levels) in 2005 to that in 2009?
Offer a terse response. 0.96. What is the ratio of the Persistence rate to the last grade of primary education (%) of Nigeria in 2005 to that in 2009?
Provide a succinct answer. 0.98. What is the ratio of the Persistence rate to the last grade of primary education (%) of Paraguay in 2005 to that in 2009?
Keep it short and to the point. 0.93. What is the ratio of the Persistence rate to the last grade of primary education (%) of Middle East & North Africa (all income levels) in 2006 to that in 2007?
Offer a very short reply. 0.99. What is the ratio of the Persistence rate to the last grade of primary education (%) in Nigeria in 2006 to that in 2007?
Provide a short and direct response. 1.11. What is the ratio of the Persistence rate to the last grade of primary education (%) of Sweden in 2006 to that in 2007?
Keep it short and to the point. 0.99. What is the ratio of the Persistence rate to the last grade of primary education (%) in Middle East & North Africa (all income levels) in 2006 to that in 2008?
Your answer should be very brief. 0.99. What is the ratio of the Persistence rate to the last grade of primary education (%) of Nigeria in 2006 to that in 2008?
Ensure brevity in your answer.  0.64. What is the ratio of the Persistence rate to the last grade of primary education (%) in Middle East & North Africa (all income levels) in 2006 to that in 2009?
Your answer should be very brief. 0.97. What is the ratio of the Persistence rate to the last grade of primary education (%) of Nigeria in 2006 to that in 2009?
Make the answer very short. 0.61. What is the ratio of the Persistence rate to the last grade of primary education (%) of Paraguay in 2006 to that in 2009?
Provide a short and direct response. 0.96. What is the ratio of the Persistence rate to the last grade of primary education (%) of Middle East & North Africa (all income levels) in 2007 to that in 2008?
Keep it short and to the point. 0.99. What is the ratio of the Persistence rate to the last grade of primary education (%) in Nigeria in 2007 to that in 2008?
Provide a succinct answer. 0.57. What is the ratio of the Persistence rate to the last grade of primary education (%) of Paraguay in 2007 to that in 2008?
Offer a terse response. 1.01. What is the ratio of the Persistence rate to the last grade of primary education (%) of Middle East & North Africa (all income levels) in 2007 to that in 2009?
Your answer should be very brief. 0.98. What is the ratio of the Persistence rate to the last grade of primary education (%) in Nigeria in 2007 to that in 2009?
Your answer should be compact. 0.55. What is the ratio of the Persistence rate to the last grade of primary education (%) in Paraguay in 2007 to that in 2009?
Give a very brief answer. 0.97. What is the ratio of the Persistence rate to the last grade of primary education (%) in Sweden in 2007 to that in 2009?
Give a very brief answer. 1. What is the ratio of the Persistence rate to the last grade of primary education (%) in Nigeria in 2008 to that in 2009?
Provide a succinct answer. 0.97. What is the ratio of the Persistence rate to the last grade of primary education (%) in Paraguay in 2008 to that in 2009?
Offer a terse response. 0.96. What is the difference between the highest and the second highest Persistence rate to the last grade of primary education (%) of Middle East & North Africa (all income levels)?
Offer a very short reply. 1.12. What is the difference between the highest and the second highest Persistence rate to the last grade of primary education (%) of Nigeria?
Give a very brief answer. 1.84. What is the difference between the highest and the second highest Persistence rate to the last grade of primary education (%) of Paraguay?
Your response must be concise. 2.53. What is the difference between the highest and the second highest Persistence rate to the last grade of primary education (%) of Sweden?
Your answer should be compact. 0.16. What is the difference between the highest and the lowest Persistence rate to the last grade of primary education (%) in Middle East & North Africa (all income levels)?
Offer a very short reply. 3.76. What is the difference between the highest and the lowest Persistence rate to the last grade of primary education (%) in Nigeria?
Provide a short and direct response. 36.66. What is the difference between the highest and the lowest Persistence rate to the last grade of primary education (%) of Paraguay?
Your answer should be very brief. 8.43. What is the difference between the highest and the lowest Persistence rate to the last grade of primary education (%) of Sweden?
Provide a short and direct response. 0.83. 